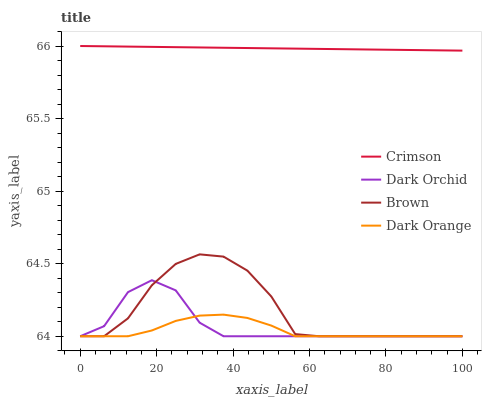Does Dark Orange have the minimum area under the curve?
Answer yes or no. Yes. Does Crimson have the maximum area under the curve?
Answer yes or no. Yes. Does Brown have the minimum area under the curve?
Answer yes or no. No. Does Brown have the maximum area under the curve?
Answer yes or no. No. Is Crimson the smoothest?
Answer yes or no. Yes. Is Brown the roughest?
Answer yes or no. Yes. Is Dark Orchid the smoothest?
Answer yes or no. No. Is Dark Orchid the roughest?
Answer yes or no. No. Does Brown have the lowest value?
Answer yes or no. Yes. Does Crimson have the highest value?
Answer yes or no. Yes. Does Brown have the highest value?
Answer yes or no. No. Is Dark Orange less than Crimson?
Answer yes or no. Yes. Is Crimson greater than Brown?
Answer yes or no. Yes. Does Brown intersect Dark Orange?
Answer yes or no. Yes. Is Brown less than Dark Orange?
Answer yes or no. No. Is Brown greater than Dark Orange?
Answer yes or no. No. Does Dark Orange intersect Crimson?
Answer yes or no. No. 